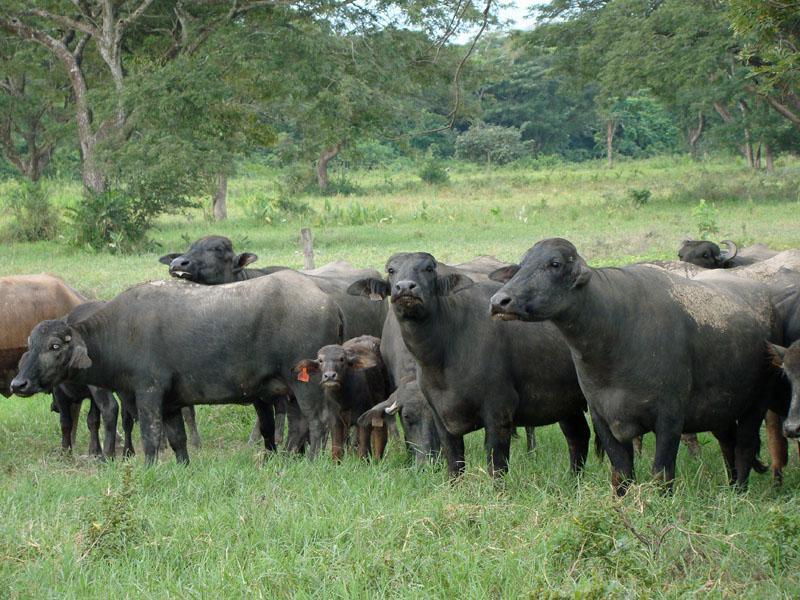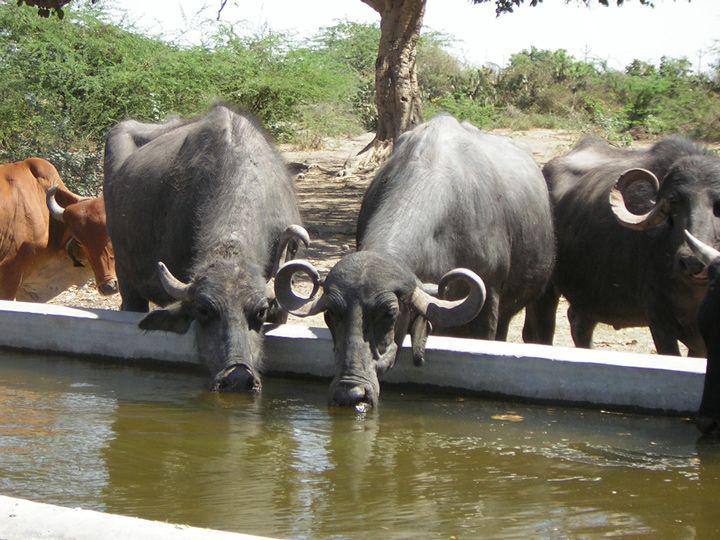The first image is the image on the left, the second image is the image on the right. Given the left and right images, does the statement "Each image shows a group of cattle-type animals walking down a path, and the right image shows a man holding a stick walking behind some of them." hold true? Answer yes or no. No. The first image is the image on the left, the second image is the image on the right. Assess this claim about the two images: "There is a man standing with some cows in the image on the right.". Correct or not? Answer yes or no. No. 